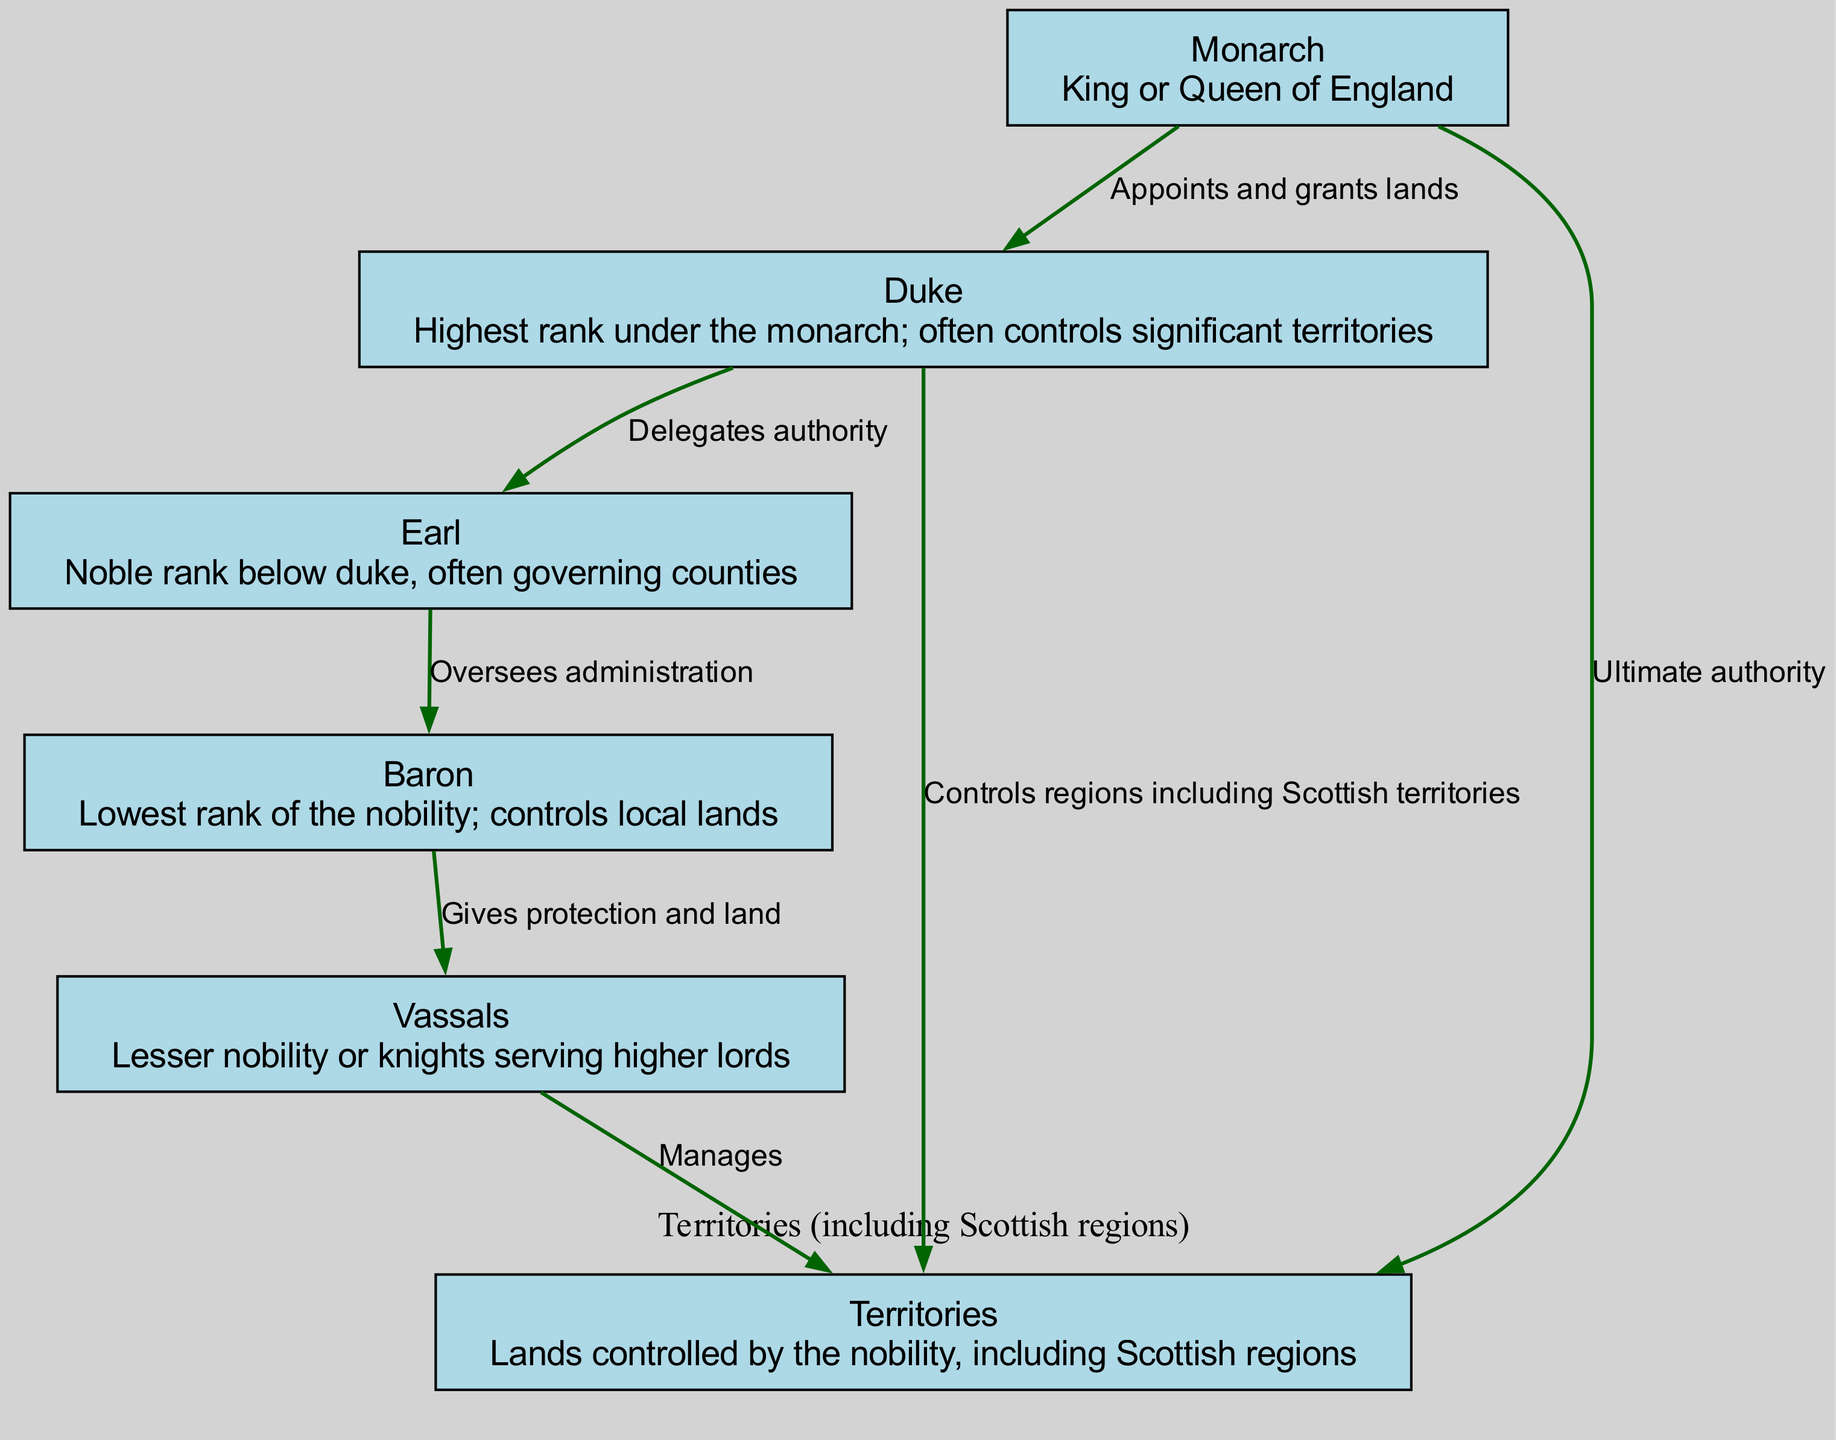What is the highest rank in the English nobility? The diagram shows the monarch as the highest rank, indicating the King or Queen of England holds this position.
Answer: Monarch How many nodes are present in the diagram? By counting the distinct entities in the nodes section, there are six nodes representing different ranks and territories.
Answer: 6 What role does a duke play in Scotland? The diagram indicates that a duke controls regions, explicitly including Scottish territories, implying significant governance in those areas.
Answer: Controls regions including Scottish territories Which rank oversees the administration of barons? The edge from earl to baron demonstrates that the earl is responsible for overseeing the administration of the barons.
Answer: Earl What relationship does the monarch have with territories? The arrow from the monarch to territories signifies that the monarch holds ultimate authority over all lands, including Scottish regions.
Answer: Ultimate authority How many levels are there in the hierarchy of English nobility shown in the diagram? The hierarchy displayed includes five levels: Monarch, Duke, Earl, Baron, and Vassals, suggesting a clear structure of authority.
Answer: 5 What action does a baron perform for vassals? The edge from baron to vassals denotes that a baron gives protection and land to lesser nobility or knights.
Answer: Gives protection and land Who delegates authority to earls? The connection from duke to earl illustrates that the duke is the one who delegates authority within the hierarchy.
Answer: Duke What is managed by vassals? According to the diagram, vassals are responsible for managing the territories assigned to them, which can include Scottish regions.
Answer: Manages 